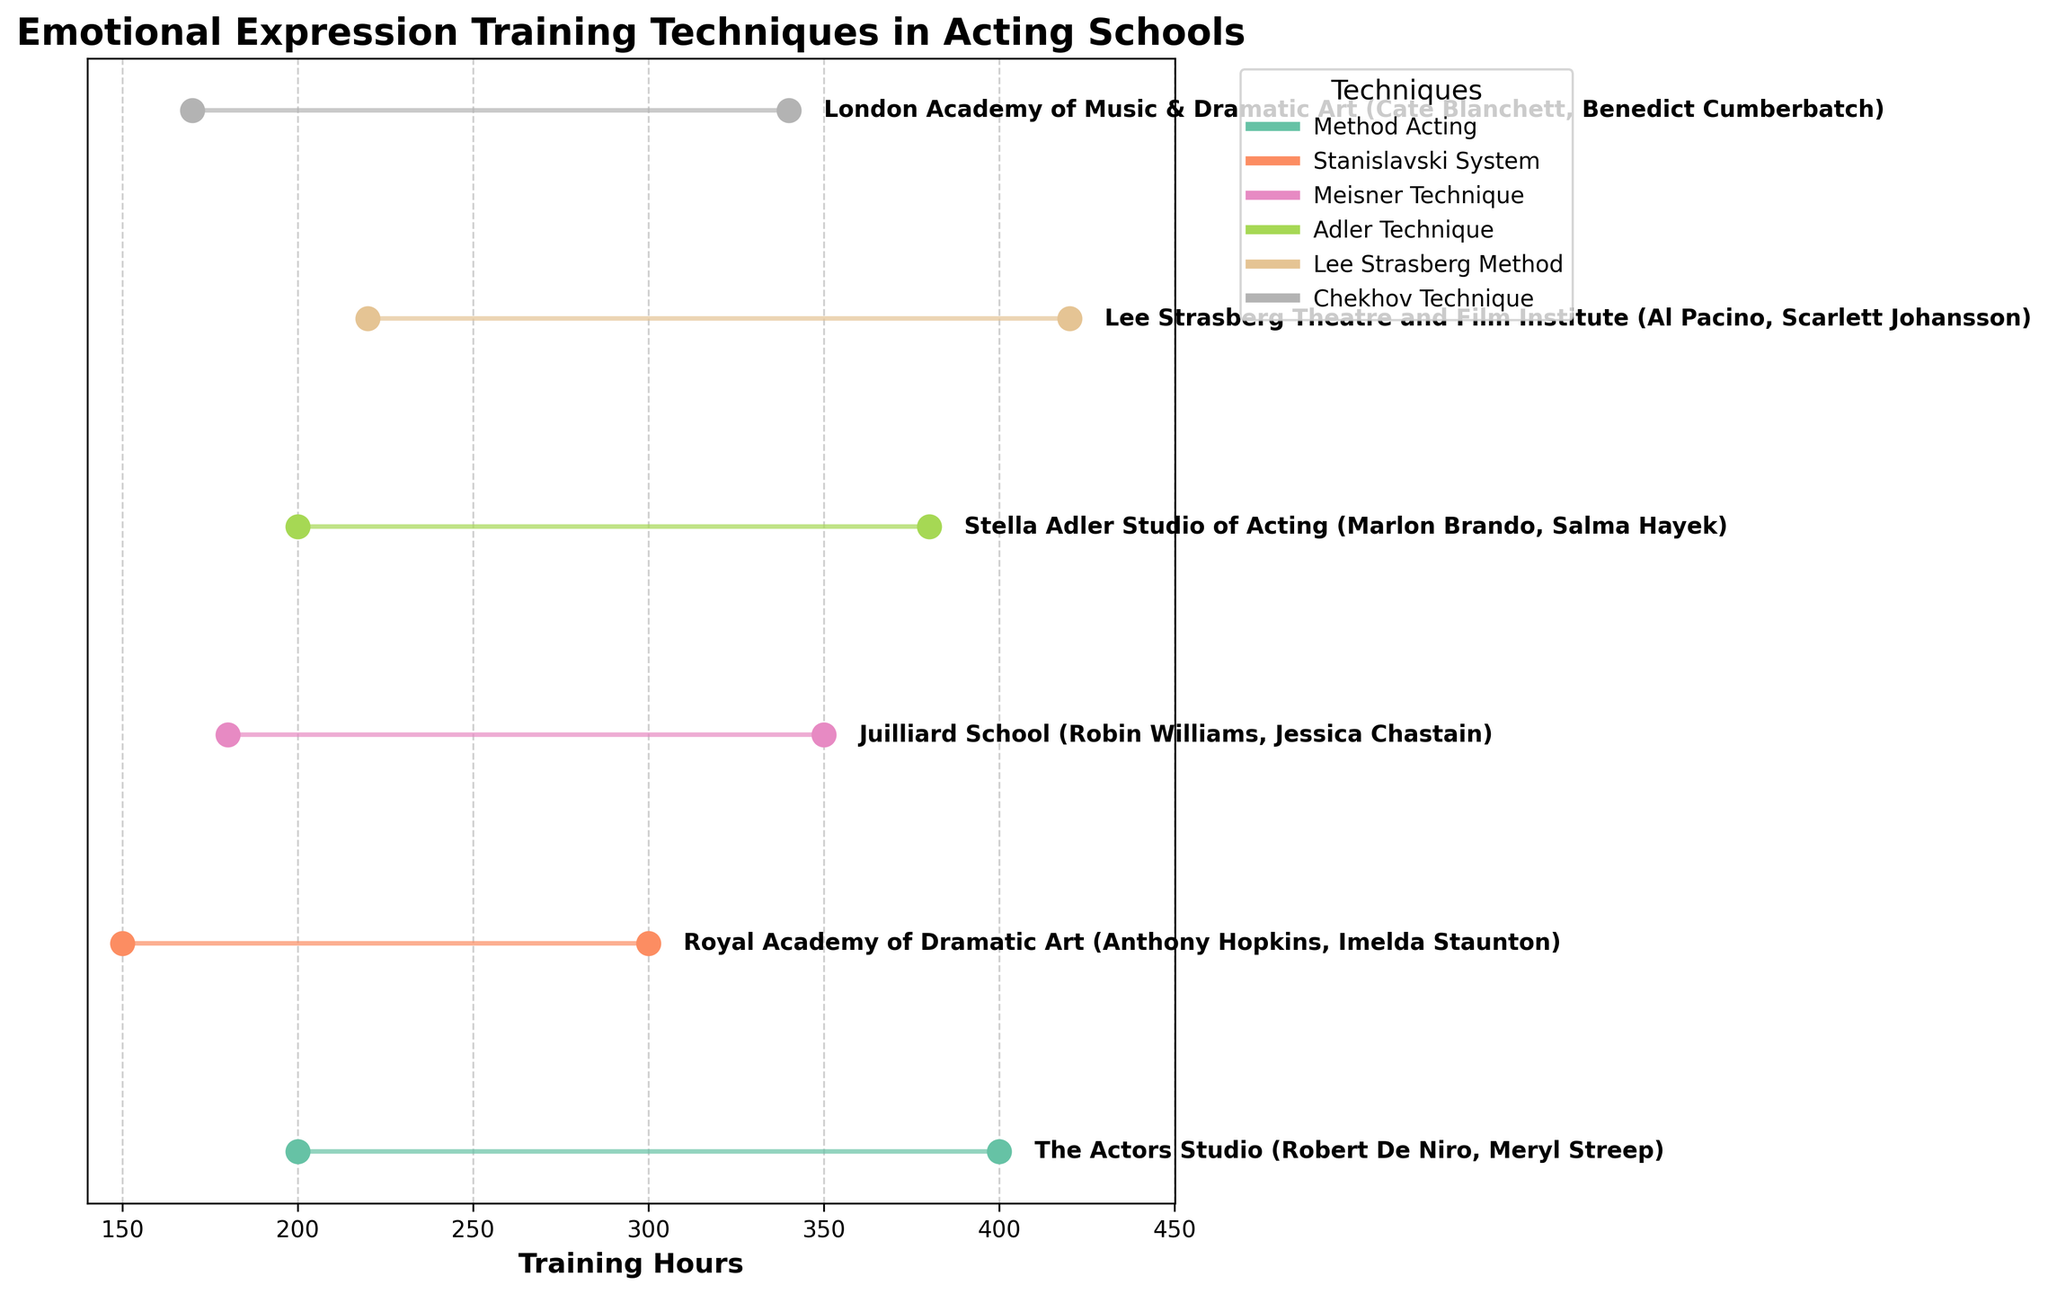Which training technique involves the most hours of training according to the figure? To find this, look for the range of hours on the x-axis for each acting technique. The Lee Strasberg Method, with ranges between 220 and 420 hours, covers the most hours.
Answer: Lee Strasberg Method What is the title of the figure? The title can be found at the top of the figure, it reads as 'Emotional Expression Training Techniques in Acting Schools'.
Answer: Emotional Expression Training Techniques in Acting Schools How many different emotional expression training techniques are displayed in the figure? To determine this, count the unique legends or techniques represented on the figure. There are five techniques: Method Acting, Stanislavski System, Meisner Technique, Adler Technique, and Chekhov Technique.
Answer: 5 Which acting school has the narrowest range of training hours? By comparing the length of the lines representing each acting school's training hours, the Royal Academy of Dramatic Art (Stanislavski System) has the narrowest range: 150 to 300 hours, a spread of 150 hours.
Answer: Royal Academy of Dramatic Art Who are the alumni of Stella Adler Studio of Acting and what technique did they train in? Refer to the text labels at the end of the line for Stella Adler Studio of Acting to find the alumni and the training technique. They trained using the Adler Technique, and the alumni are Marlon Brando and Salma Hayek.
Answer: Marlon Brando and Salma Hayek, Adler Technique Which technique is shared between The Actors Studio and Lee Strasberg Theatre and Film Institute? Look for the techniques associated with these schools. Both schools have different techniques: Method Acting for The Actors Studio and Lee Strasberg Method for Lee Strasberg Theatre and Film Institute. Thus, no technique is shared.
Answer: None What is the difference between the maximum training hours of Juilliard School and London Academy of Music & Dramatic Art? Find the maximum values on the x-axis for Juilliard School (350 hours for Meisner Technique) and London Academy of Music & Dramatic Art (340 hours for Chekhov Technique). The difference is 350 - 340 = 10 hours.
Answer: 10 hours Which technique has the lowest minimum training hours according to the figure? Compare the minimum training hours on the x-axis for each technique. The Stanislavski System, taught at Royal Academy of Dramatic Art, has the lowest minimum training hours of 150.
Answer: Stanislavski System What is the average of the maximum training hours for Method Acting and Lee Strasberg Method? The maximum hours for Method Acting is 400, and for Lee Strasberg Method, it is 420. The average is calculated as (400 + 420) / 2 = 410 hours.
Answer: 410 hours 